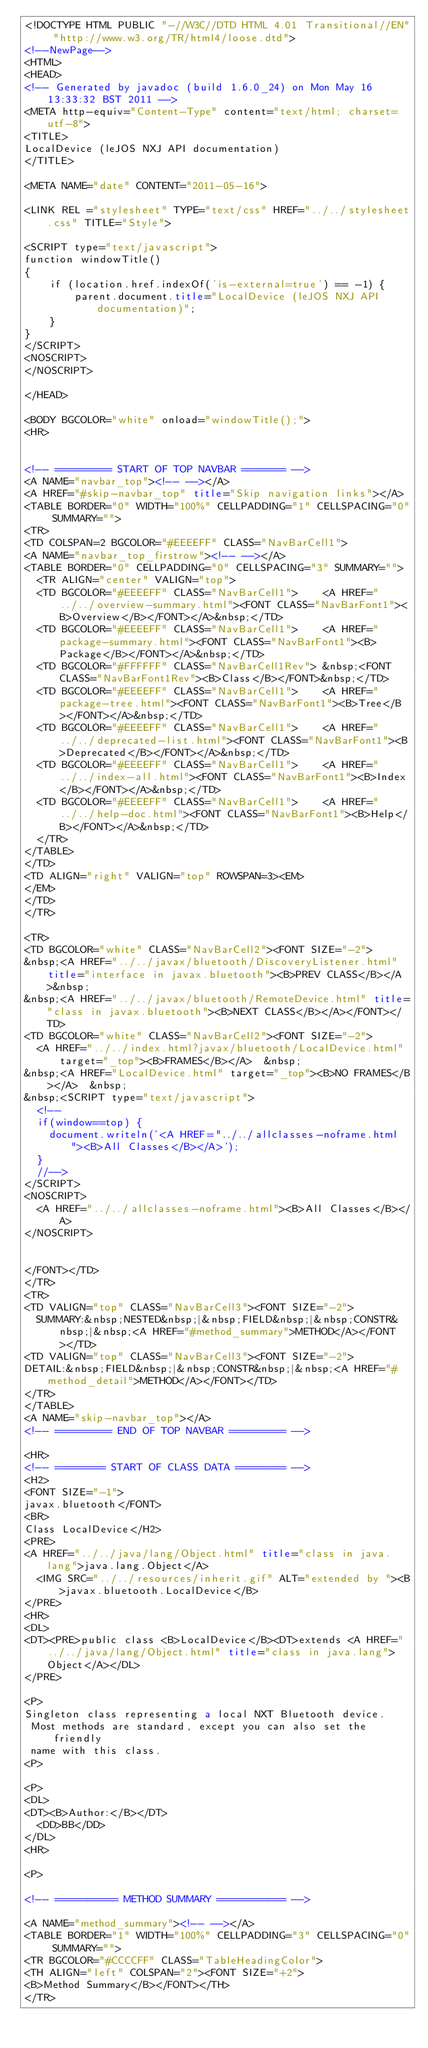<code> <loc_0><loc_0><loc_500><loc_500><_HTML_><!DOCTYPE HTML PUBLIC "-//W3C//DTD HTML 4.01 Transitional//EN" "http://www.w3.org/TR/html4/loose.dtd">
<!--NewPage-->
<HTML>
<HEAD>
<!-- Generated by javadoc (build 1.6.0_24) on Mon May 16 13:33:32 BST 2011 -->
<META http-equiv="Content-Type" content="text/html; charset=utf-8">
<TITLE>
LocalDevice (leJOS NXJ API documentation)
</TITLE>

<META NAME="date" CONTENT="2011-05-16">

<LINK REL ="stylesheet" TYPE="text/css" HREF="../../stylesheet.css" TITLE="Style">

<SCRIPT type="text/javascript">
function windowTitle()
{
    if (location.href.indexOf('is-external=true') == -1) {
        parent.document.title="LocalDevice (leJOS NXJ API documentation)";
    }
}
</SCRIPT>
<NOSCRIPT>
</NOSCRIPT>

</HEAD>

<BODY BGCOLOR="white" onload="windowTitle();">
<HR>


<!-- ========= START OF TOP NAVBAR ======= -->
<A NAME="navbar_top"><!-- --></A>
<A HREF="#skip-navbar_top" title="Skip navigation links"></A>
<TABLE BORDER="0" WIDTH="100%" CELLPADDING="1" CELLSPACING="0" SUMMARY="">
<TR>
<TD COLSPAN=2 BGCOLOR="#EEEEFF" CLASS="NavBarCell1">
<A NAME="navbar_top_firstrow"><!-- --></A>
<TABLE BORDER="0" CELLPADDING="0" CELLSPACING="3" SUMMARY="">
  <TR ALIGN="center" VALIGN="top">
  <TD BGCOLOR="#EEEEFF" CLASS="NavBarCell1">    <A HREF="../../overview-summary.html"><FONT CLASS="NavBarFont1"><B>Overview</B></FONT></A>&nbsp;</TD>
  <TD BGCOLOR="#EEEEFF" CLASS="NavBarCell1">    <A HREF="package-summary.html"><FONT CLASS="NavBarFont1"><B>Package</B></FONT></A>&nbsp;</TD>
  <TD BGCOLOR="#FFFFFF" CLASS="NavBarCell1Rev"> &nbsp;<FONT CLASS="NavBarFont1Rev"><B>Class</B></FONT>&nbsp;</TD>
  <TD BGCOLOR="#EEEEFF" CLASS="NavBarCell1">    <A HREF="package-tree.html"><FONT CLASS="NavBarFont1"><B>Tree</B></FONT></A>&nbsp;</TD>
  <TD BGCOLOR="#EEEEFF" CLASS="NavBarCell1">    <A HREF="../../deprecated-list.html"><FONT CLASS="NavBarFont1"><B>Deprecated</B></FONT></A>&nbsp;</TD>
  <TD BGCOLOR="#EEEEFF" CLASS="NavBarCell1">    <A HREF="../../index-all.html"><FONT CLASS="NavBarFont1"><B>Index</B></FONT></A>&nbsp;</TD>
  <TD BGCOLOR="#EEEEFF" CLASS="NavBarCell1">    <A HREF="../../help-doc.html"><FONT CLASS="NavBarFont1"><B>Help</B></FONT></A>&nbsp;</TD>
  </TR>
</TABLE>
</TD>
<TD ALIGN="right" VALIGN="top" ROWSPAN=3><EM>
</EM>
</TD>
</TR>

<TR>
<TD BGCOLOR="white" CLASS="NavBarCell2"><FONT SIZE="-2">
&nbsp;<A HREF="../../javax/bluetooth/DiscoveryListener.html" title="interface in javax.bluetooth"><B>PREV CLASS</B></A>&nbsp;
&nbsp;<A HREF="../../javax/bluetooth/RemoteDevice.html" title="class in javax.bluetooth"><B>NEXT CLASS</B></A></FONT></TD>
<TD BGCOLOR="white" CLASS="NavBarCell2"><FONT SIZE="-2">
  <A HREF="../../index.html?javax/bluetooth/LocalDevice.html" target="_top"><B>FRAMES</B></A>  &nbsp;
&nbsp;<A HREF="LocalDevice.html" target="_top"><B>NO FRAMES</B></A>  &nbsp;
&nbsp;<SCRIPT type="text/javascript">
  <!--
  if(window==top) {
    document.writeln('<A HREF="../../allclasses-noframe.html"><B>All Classes</B></A>');
  }
  //-->
</SCRIPT>
<NOSCRIPT>
  <A HREF="../../allclasses-noframe.html"><B>All Classes</B></A>
</NOSCRIPT>


</FONT></TD>
</TR>
<TR>
<TD VALIGN="top" CLASS="NavBarCell3"><FONT SIZE="-2">
  SUMMARY:&nbsp;NESTED&nbsp;|&nbsp;FIELD&nbsp;|&nbsp;CONSTR&nbsp;|&nbsp;<A HREF="#method_summary">METHOD</A></FONT></TD>
<TD VALIGN="top" CLASS="NavBarCell3"><FONT SIZE="-2">
DETAIL:&nbsp;FIELD&nbsp;|&nbsp;CONSTR&nbsp;|&nbsp;<A HREF="#method_detail">METHOD</A></FONT></TD>
</TR>
</TABLE>
<A NAME="skip-navbar_top"></A>
<!-- ========= END OF TOP NAVBAR ========= -->

<HR>
<!-- ======== START OF CLASS DATA ======== -->
<H2>
<FONT SIZE="-1">
javax.bluetooth</FONT>
<BR>
Class LocalDevice</H2>
<PRE>
<A HREF="../../java/lang/Object.html" title="class in java.lang">java.lang.Object</A>
  <IMG SRC="../../resources/inherit.gif" ALT="extended by "><B>javax.bluetooth.LocalDevice</B>
</PRE>
<HR>
<DL>
<DT><PRE>public class <B>LocalDevice</B><DT>extends <A HREF="../../java/lang/Object.html" title="class in java.lang">Object</A></DL>
</PRE>

<P>
Singleton class representing a local NXT Bluetooth device.
 Most methods are standard, except you can also set the friendly
 name with this class.
<P>

<P>
<DL>
<DT><B>Author:</B></DT>
  <DD>BB</DD>
</DL>
<HR>

<P>

<!-- ========== METHOD SUMMARY =========== -->

<A NAME="method_summary"><!-- --></A>
<TABLE BORDER="1" WIDTH="100%" CELLPADDING="3" CELLSPACING="0" SUMMARY="">
<TR BGCOLOR="#CCCCFF" CLASS="TableHeadingColor">
<TH ALIGN="left" COLSPAN="2"><FONT SIZE="+2">
<B>Method Summary</B></FONT></TH>
</TR></code> 